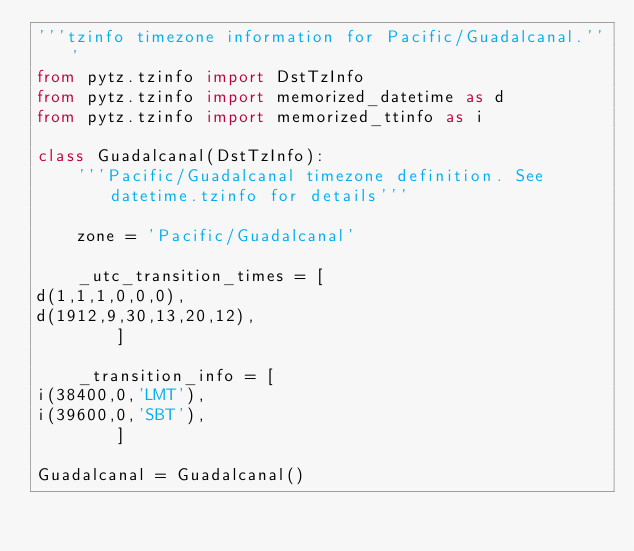<code> <loc_0><loc_0><loc_500><loc_500><_Python_>'''tzinfo timezone information for Pacific/Guadalcanal.'''
from pytz.tzinfo import DstTzInfo
from pytz.tzinfo import memorized_datetime as d
from pytz.tzinfo import memorized_ttinfo as i

class Guadalcanal(DstTzInfo):
    '''Pacific/Guadalcanal timezone definition. See datetime.tzinfo for details'''

    zone = 'Pacific/Guadalcanal'

    _utc_transition_times = [
d(1,1,1,0,0,0),
d(1912,9,30,13,20,12),
        ]

    _transition_info = [
i(38400,0,'LMT'),
i(39600,0,'SBT'),
        ]

Guadalcanal = Guadalcanal()

</code> 